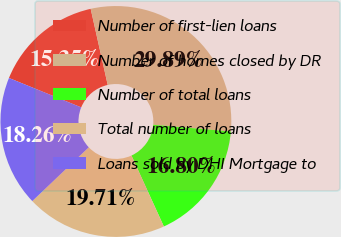Convert chart. <chart><loc_0><loc_0><loc_500><loc_500><pie_chart><fcel>Number of first-lien loans<fcel>Number of homes closed by DR<fcel>Number of total loans<fcel>Total number of loans<fcel>Loans sold by DHI Mortgage to<nl><fcel>15.35%<fcel>29.89%<fcel>16.8%<fcel>19.71%<fcel>18.26%<nl></chart> 